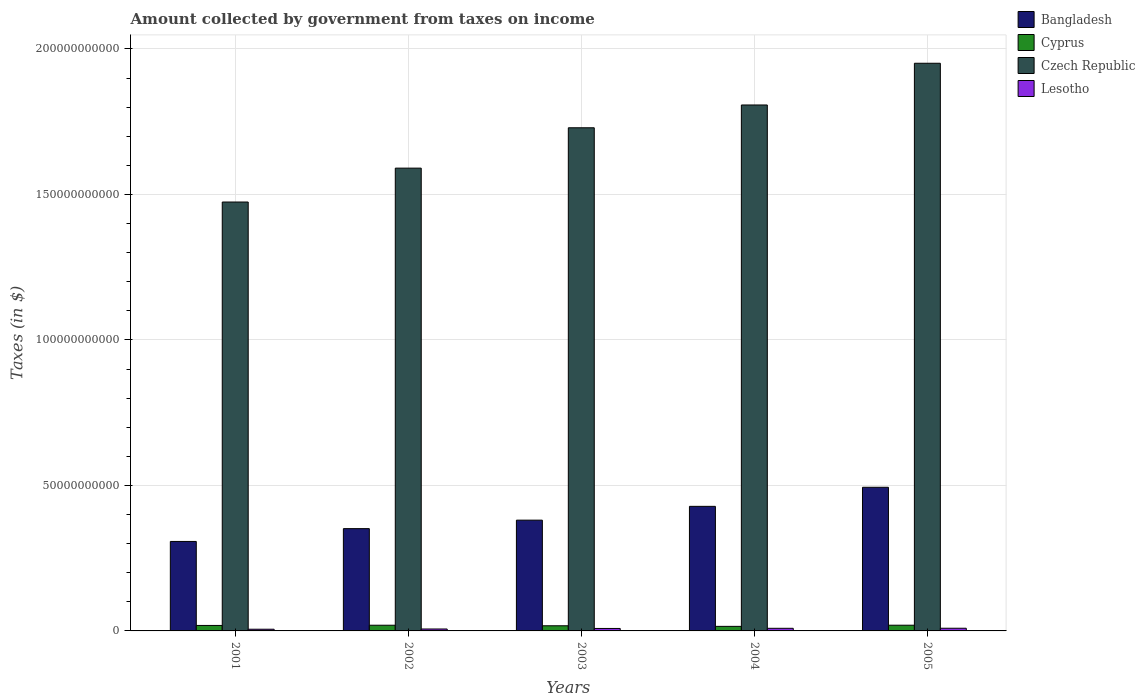How many groups of bars are there?
Provide a succinct answer. 5. In how many cases, is the number of bars for a given year not equal to the number of legend labels?
Provide a succinct answer. 0. What is the amount collected by government from taxes on income in Lesotho in 2005?
Ensure brevity in your answer.  9.20e+08. Across all years, what is the maximum amount collected by government from taxes on income in Bangladesh?
Offer a terse response. 4.94e+1. Across all years, what is the minimum amount collected by government from taxes on income in Czech Republic?
Your answer should be compact. 1.47e+11. In which year was the amount collected by government from taxes on income in Cyprus maximum?
Your answer should be very brief. 2005. In which year was the amount collected by government from taxes on income in Bangladesh minimum?
Make the answer very short. 2001. What is the total amount collected by government from taxes on income in Lesotho in the graph?
Offer a very short reply. 3.90e+09. What is the difference between the amount collected by government from taxes on income in Bangladesh in 2002 and that in 2005?
Make the answer very short. -1.42e+1. What is the difference between the amount collected by government from taxes on income in Czech Republic in 2001 and the amount collected by government from taxes on income in Lesotho in 2002?
Offer a terse response. 1.47e+11. What is the average amount collected by government from taxes on income in Cyprus per year?
Make the answer very short. 1.83e+09. In the year 2003, what is the difference between the amount collected by government from taxes on income in Cyprus and amount collected by government from taxes on income in Bangladesh?
Your answer should be compact. -3.63e+1. What is the ratio of the amount collected by government from taxes on income in Bangladesh in 2001 to that in 2003?
Ensure brevity in your answer.  0.81. What is the difference between the highest and the second highest amount collected by government from taxes on income in Bangladesh?
Offer a very short reply. 6.56e+09. What is the difference between the highest and the lowest amount collected by government from taxes on income in Lesotho?
Make the answer very short. 3.40e+08. Is the sum of the amount collected by government from taxes on income in Cyprus in 2001 and 2005 greater than the maximum amount collected by government from taxes on income in Czech Republic across all years?
Offer a very short reply. No. What does the 2nd bar from the left in 2004 represents?
Keep it short and to the point. Cyprus. What does the 3rd bar from the right in 2003 represents?
Ensure brevity in your answer.  Cyprus. Is it the case that in every year, the sum of the amount collected by government from taxes on income in Cyprus and amount collected by government from taxes on income in Czech Republic is greater than the amount collected by government from taxes on income in Bangladesh?
Make the answer very short. Yes. How many bars are there?
Give a very brief answer. 20. Are all the bars in the graph horizontal?
Ensure brevity in your answer.  No. Does the graph contain any zero values?
Offer a terse response. No. Does the graph contain grids?
Keep it short and to the point. Yes. Where does the legend appear in the graph?
Ensure brevity in your answer.  Top right. How many legend labels are there?
Your answer should be compact. 4. How are the legend labels stacked?
Make the answer very short. Vertical. What is the title of the graph?
Ensure brevity in your answer.  Amount collected by government from taxes on income. What is the label or title of the X-axis?
Provide a succinct answer. Years. What is the label or title of the Y-axis?
Keep it short and to the point. Taxes (in $). What is the Taxes (in $) of Bangladesh in 2001?
Offer a very short reply. 3.07e+1. What is the Taxes (in $) in Cyprus in 2001?
Ensure brevity in your answer.  1.88e+09. What is the Taxes (in $) in Czech Republic in 2001?
Give a very brief answer. 1.47e+11. What is the Taxes (in $) in Lesotho in 2001?
Your response must be concise. 5.80e+08. What is the Taxes (in $) of Bangladesh in 2002?
Your response must be concise. 3.52e+1. What is the Taxes (in $) of Cyprus in 2002?
Keep it short and to the point. 1.96e+09. What is the Taxes (in $) of Czech Republic in 2002?
Your response must be concise. 1.59e+11. What is the Taxes (in $) of Lesotho in 2002?
Your answer should be compact. 6.63e+08. What is the Taxes (in $) in Bangladesh in 2003?
Offer a terse response. 3.81e+1. What is the Taxes (in $) of Cyprus in 2003?
Keep it short and to the point. 1.77e+09. What is the Taxes (in $) in Czech Republic in 2003?
Your answer should be compact. 1.73e+11. What is the Taxes (in $) of Lesotho in 2003?
Ensure brevity in your answer.  8.44e+08. What is the Taxes (in $) in Bangladesh in 2004?
Provide a succinct answer. 4.28e+1. What is the Taxes (in $) of Cyprus in 2004?
Provide a short and direct response. 1.56e+09. What is the Taxes (in $) of Czech Republic in 2004?
Your response must be concise. 1.81e+11. What is the Taxes (in $) in Lesotho in 2004?
Make the answer very short. 8.97e+08. What is the Taxes (in $) of Bangladesh in 2005?
Provide a short and direct response. 4.94e+1. What is the Taxes (in $) of Cyprus in 2005?
Offer a terse response. 1.96e+09. What is the Taxes (in $) of Czech Republic in 2005?
Your answer should be very brief. 1.95e+11. What is the Taxes (in $) of Lesotho in 2005?
Provide a succinct answer. 9.20e+08. Across all years, what is the maximum Taxes (in $) in Bangladesh?
Make the answer very short. 4.94e+1. Across all years, what is the maximum Taxes (in $) in Cyprus?
Your answer should be compact. 1.96e+09. Across all years, what is the maximum Taxes (in $) of Czech Republic?
Offer a very short reply. 1.95e+11. Across all years, what is the maximum Taxes (in $) in Lesotho?
Make the answer very short. 9.20e+08. Across all years, what is the minimum Taxes (in $) in Bangladesh?
Ensure brevity in your answer.  3.07e+1. Across all years, what is the minimum Taxes (in $) of Cyprus?
Give a very brief answer. 1.56e+09. Across all years, what is the minimum Taxes (in $) in Czech Republic?
Your response must be concise. 1.47e+11. Across all years, what is the minimum Taxes (in $) of Lesotho?
Offer a terse response. 5.80e+08. What is the total Taxes (in $) in Bangladesh in the graph?
Provide a short and direct response. 1.96e+11. What is the total Taxes (in $) of Cyprus in the graph?
Keep it short and to the point. 9.13e+09. What is the total Taxes (in $) of Czech Republic in the graph?
Your response must be concise. 8.55e+11. What is the total Taxes (in $) of Lesotho in the graph?
Provide a succinct answer. 3.90e+09. What is the difference between the Taxes (in $) in Bangladesh in 2001 and that in 2002?
Your answer should be compact. -4.40e+09. What is the difference between the Taxes (in $) of Cyprus in 2001 and that in 2002?
Make the answer very short. -7.14e+07. What is the difference between the Taxes (in $) of Czech Republic in 2001 and that in 2002?
Offer a very short reply. -1.16e+1. What is the difference between the Taxes (in $) in Lesotho in 2001 and that in 2002?
Your answer should be very brief. -8.36e+07. What is the difference between the Taxes (in $) of Bangladesh in 2001 and that in 2003?
Ensure brevity in your answer.  -7.31e+09. What is the difference between the Taxes (in $) of Cyprus in 2001 and that in 2003?
Provide a succinct answer. 1.18e+08. What is the difference between the Taxes (in $) in Czech Republic in 2001 and that in 2003?
Offer a terse response. -2.55e+1. What is the difference between the Taxes (in $) in Lesotho in 2001 and that in 2003?
Offer a terse response. -2.65e+08. What is the difference between the Taxes (in $) of Bangladesh in 2001 and that in 2004?
Keep it short and to the point. -1.21e+1. What is the difference between the Taxes (in $) of Cyprus in 2001 and that in 2004?
Make the answer very short. 3.21e+08. What is the difference between the Taxes (in $) of Czech Republic in 2001 and that in 2004?
Your answer should be compact. -3.33e+1. What is the difference between the Taxes (in $) in Lesotho in 2001 and that in 2004?
Provide a succinct answer. -3.17e+08. What is the difference between the Taxes (in $) of Bangladesh in 2001 and that in 2005?
Provide a succinct answer. -1.86e+1. What is the difference between the Taxes (in $) of Cyprus in 2001 and that in 2005?
Provide a short and direct response. -7.60e+07. What is the difference between the Taxes (in $) in Czech Republic in 2001 and that in 2005?
Offer a very short reply. -4.77e+1. What is the difference between the Taxes (in $) of Lesotho in 2001 and that in 2005?
Your response must be concise. -3.40e+08. What is the difference between the Taxes (in $) of Bangladesh in 2002 and that in 2003?
Keep it short and to the point. -2.91e+09. What is the difference between the Taxes (in $) in Cyprus in 2002 and that in 2003?
Provide a succinct answer. 1.89e+08. What is the difference between the Taxes (in $) in Czech Republic in 2002 and that in 2003?
Provide a short and direct response. -1.39e+1. What is the difference between the Taxes (in $) of Lesotho in 2002 and that in 2003?
Your answer should be very brief. -1.81e+08. What is the difference between the Taxes (in $) of Bangladesh in 2002 and that in 2004?
Your answer should be compact. -7.66e+09. What is the difference between the Taxes (in $) of Cyprus in 2002 and that in 2004?
Offer a very short reply. 3.92e+08. What is the difference between the Taxes (in $) of Czech Republic in 2002 and that in 2004?
Give a very brief answer. -2.17e+1. What is the difference between the Taxes (in $) in Lesotho in 2002 and that in 2004?
Your answer should be compact. -2.34e+08. What is the difference between the Taxes (in $) of Bangladesh in 2002 and that in 2005?
Ensure brevity in your answer.  -1.42e+1. What is the difference between the Taxes (in $) in Cyprus in 2002 and that in 2005?
Provide a succinct answer. -4.61e+06. What is the difference between the Taxes (in $) in Czech Republic in 2002 and that in 2005?
Your answer should be compact. -3.60e+1. What is the difference between the Taxes (in $) in Lesotho in 2002 and that in 2005?
Ensure brevity in your answer.  -2.57e+08. What is the difference between the Taxes (in $) in Bangladesh in 2003 and that in 2004?
Give a very brief answer. -4.74e+09. What is the difference between the Taxes (in $) in Cyprus in 2003 and that in 2004?
Offer a very short reply. 2.03e+08. What is the difference between the Taxes (in $) in Czech Republic in 2003 and that in 2004?
Offer a terse response. -7.83e+09. What is the difference between the Taxes (in $) of Lesotho in 2003 and that in 2004?
Ensure brevity in your answer.  -5.27e+07. What is the difference between the Taxes (in $) of Bangladesh in 2003 and that in 2005?
Offer a terse response. -1.13e+1. What is the difference between the Taxes (in $) of Cyprus in 2003 and that in 2005?
Make the answer very short. -1.94e+08. What is the difference between the Taxes (in $) in Czech Republic in 2003 and that in 2005?
Ensure brevity in your answer.  -2.22e+1. What is the difference between the Taxes (in $) in Lesotho in 2003 and that in 2005?
Provide a succinct answer. -7.57e+07. What is the difference between the Taxes (in $) in Bangladesh in 2004 and that in 2005?
Ensure brevity in your answer.  -6.56e+09. What is the difference between the Taxes (in $) in Cyprus in 2004 and that in 2005?
Give a very brief answer. -3.97e+08. What is the difference between the Taxes (in $) of Czech Republic in 2004 and that in 2005?
Your answer should be very brief. -1.43e+1. What is the difference between the Taxes (in $) of Lesotho in 2004 and that in 2005?
Your answer should be very brief. -2.30e+07. What is the difference between the Taxes (in $) in Bangladesh in 2001 and the Taxes (in $) in Cyprus in 2002?
Your response must be concise. 2.88e+1. What is the difference between the Taxes (in $) in Bangladesh in 2001 and the Taxes (in $) in Czech Republic in 2002?
Make the answer very short. -1.28e+11. What is the difference between the Taxes (in $) in Bangladesh in 2001 and the Taxes (in $) in Lesotho in 2002?
Provide a succinct answer. 3.01e+1. What is the difference between the Taxes (in $) of Cyprus in 2001 and the Taxes (in $) of Czech Republic in 2002?
Offer a terse response. -1.57e+11. What is the difference between the Taxes (in $) in Cyprus in 2001 and the Taxes (in $) in Lesotho in 2002?
Provide a succinct answer. 1.22e+09. What is the difference between the Taxes (in $) in Czech Republic in 2001 and the Taxes (in $) in Lesotho in 2002?
Make the answer very short. 1.47e+11. What is the difference between the Taxes (in $) in Bangladesh in 2001 and the Taxes (in $) in Cyprus in 2003?
Your response must be concise. 2.90e+1. What is the difference between the Taxes (in $) in Bangladesh in 2001 and the Taxes (in $) in Czech Republic in 2003?
Ensure brevity in your answer.  -1.42e+11. What is the difference between the Taxes (in $) of Bangladesh in 2001 and the Taxes (in $) of Lesotho in 2003?
Provide a succinct answer. 2.99e+1. What is the difference between the Taxes (in $) of Cyprus in 2001 and the Taxes (in $) of Czech Republic in 2003?
Give a very brief answer. -1.71e+11. What is the difference between the Taxes (in $) of Cyprus in 2001 and the Taxes (in $) of Lesotho in 2003?
Provide a short and direct response. 1.04e+09. What is the difference between the Taxes (in $) of Czech Republic in 2001 and the Taxes (in $) of Lesotho in 2003?
Give a very brief answer. 1.47e+11. What is the difference between the Taxes (in $) in Bangladesh in 2001 and the Taxes (in $) in Cyprus in 2004?
Provide a short and direct response. 2.92e+1. What is the difference between the Taxes (in $) of Bangladesh in 2001 and the Taxes (in $) of Czech Republic in 2004?
Give a very brief answer. -1.50e+11. What is the difference between the Taxes (in $) of Bangladesh in 2001 and the Taxes (in $) of Lesotho in 2004?
Provide a succinct answer. 2.99e+1. What is the difference between the Taxes (in $) of Cyprus in 2001 and the Taxes (in $) of Czech Republic in 2004?
Give a very brief answer. -1.79e+11. What is the difference between the Taxes (in $) of Cyprus in 2001 and the Taxes (in $) of Lesotho in 2004?
Ensure brevity in your answer.  9.87e+08. What is the difference between the Taxes (in $) in Czech Republic in 2001 and the Taxes (in $) in Lesotho in 2004?
Ensure brevity in your answer.  1.46e+11. What is the difference between the Taxes (in $) of Bangladesh in 2001 and the Taxes (in $) of Cyprus in 2005?
Offer a terse response. 2.88e+1. What is the difference between the Taxes (in $) in Bangladesh in 2001 and the Taxes (in $) in Czech Republic in 2005?
Provide a short and direct response. -1.64e+11. What is the difference between the Taxes (in $) in Bangladesh in 2001 and the Taxes (in $) in Lesotho in 2005?
Your answer should be very brief. 2.98e+1. What is the difference between the Taxes (in $) of Cyprus in 2001 and the Taxes (in $) of Czech Republic in 2005?
Ensure brevity in your answer.  -1.93e+11. What is the difference between the Taxes (in $) of Cyprus in 2001 and the Taxes (in $) of Lesotho in 2005?
Ensure brevity in your answer.  9.64e+08. What is the difference between the Taxes (in $) of Czech Republic in 2001 and the Taxes (in $) of Lesotho in 2005?
Provide a short and direct response. 1.46e+11. What is the difference between the Taxes (in $) in Bangladesh in 2002 and the Taxes (in $) in Cyprus in 2003?
Ensure brevity in your answer.  3.34e+1. What is the difference between the Taxes (in $) of Bangladesh in 2002 and the Taxes (in $) of Czech Republic in 2003?
Provide a short and direct response. -1.38e+11. What is the difference between the Taxes (in $) of Bangladesh in 2002 and the Taxes (in $) of Lesotho in 2003?
Give a very brief answer. 3.43e+1. What is the difference between the Taxes (in $) of Cyprus in 2002 and the Taxes (in $) of Czech Republic in 2003?
Ensure brevity in your answer.  -1.71e+11. What is the difference between the Taxes (in $) of Cyprus in 2002 and the Taxes (in $) of Lesotho in 2003?
Offer a terse response. 1.11e+09. What is the difference between the Taxes (in $) of Czech Republic in 2002 and the Taxes (in $) of Lesotho in 2003?
Make the answer very short. 1.58e+11. What is the difference between the Taxes (in $) of Bangladesh in 2002 and the Taxes (in $) of Cyprus in 2004?
Ensure brevity in your answer.  3.36e+1. What is the difference between the Taxes (in $) of Bangladesh in 2002 and the Taxes (in $) of Czech Republic in 2004?
Your response must be concise. -1.46e+11. What is the difference between the Taxes (in $) in Bangladesh in 2002 and the Taxes (in $) in Lesotho in 2004?
Give a very brief answer. 3.43e+1. What is the difference between the Taxes (in $) of Cyprus in 2002 and the Taxes (in $) of Czech Republic in 2004?
Offer a terse response. -1.79e+11. What is the difference between the Taxes (in $) of Cyprus in 2002 and the Taxes (in $) of Lesotho in 2004?
Give a very brief answer. 1.06e+09. What is the difference between the Taxes (in $) of Czech Republic in 2002 and the Taxes (in $) of Lesotho in 2004?
Provide a succinct answer. 1.58e+11. What is the difference between the Taxes (in $) in Bangladesh in 2002 and the Taxes (in $) in Cyprus in 2005?
Your answer should be very brief. 3.32e+1. What is the difference between the Taxes (in $) in Bangladesh in 2002 and the Taxes (in $) in Czech Republic in 2005?
Provide a short and direct response. -1.60e+11. What is the difference between the Taxes (in $) in Bangladesh in 2002 and the Taxes (in $) in Lesotho in 2005?
Your answer should be very brief. 3.42e+1. What is the difference between the Taxes (in $) of Cyprus in 2002 and the Taxes (in $) of Czech Republic in 2005?
Provide a short and direct response. -1.93e+11. What is the difference between the Taxes (in $) of Cyprus in 2002 and the Taxes (in $) of Lesotho in 2005?
Keep it short and to the point. 1.04e+09. What is the difference between the Taxes (in $) in Czech Republic in 2002 and the Taxes (in $) in Lesotho in 2005?
Give a very brief answer. 1.58e+11. What is the difference between the Taxes (in $) of Bangladesh in 2003 and the Taxes (in $) of Cyprus in 2004?
Offer a very short reply. 3.65e+1. What is the difference between the Taxes (in $) of Bangladesh in 2003 and the Taxes (in $) of Czech Republic in 2004?
Give a very brief answer. -1.43e+11. What is the difference between the Taxes (in $) in Bangladesh in 2003 and the Taxes (in $) in Lesotho in 2004?
Ensure brevity in your answer.  3.72e+1. What is the difference between the Taxes (in $) of Cyprus in 2003 and the Taxes (in $) of Czech Republic in 2004?
Offer a terse response. -1.79e+11. What is the difference between the Taxes (in $) of Cyprus in 2003 and the Taxes (in $) of Lesotho in 2004?
Provide a short and direct response. 8.69e+08. What is the difference between the Taxes (in $) in Czech Republic in 2003 and the Taxes (in $) in Lesotho in 2004?
Ensure brevity in your answer.  1.72e+11. What is the difference between the Taxes (in $) of Bangladesh in 2003 and the Taxes (in $) of Cyprus in 2005?
Provide a short and direct response. 3.61e+1. What is the difference between the Taxes (in $) in Bangladesh in 2003 and the Taxes (in $) in Czech Republic in 2005?
Provide a succinct answer. -1.57e+11. What is the difference between the Taxes (in $) in Bangladesh in 2003 and the Taxes (in $) in Lesotho in 2005?
Give a very brief answer. 3.71e+1. What is the difference between the Taxes (in $) in Cyprus in 2003 and the Taxes (in $) in Czech Republic in 2005?
Keep it short and to the point. -1.93e+11. What is the difference between the Taxes (in $) in Cyprus in 2003 and the Taxes (in $) in Lesotho in 2005?
Keep it short and to the point. 8.46e+08. What is the difference between the Taxes (in $) in Czech Republic in 2003 and the Taxes (in $) in Lesotho in 2005?
Offer a terse response. 1.72e+11. What is the difference between the Taxes (in $) in Bangladesh in 2004 and the Taxes (in $) in Cyprus in 2005?
Keep it short and to the point. 4.08e+1. What is the difference between the Taxes (in $) in Bangladesh in 2004 and the Taxes (in $) in Czech Republic in 2005?
Ensure brevity in your answer.  -1.52e+11. What is the difference between the Taxes (in $) in Bangladesh in 2004 and the Taxes (in $) in Lesotho in 2005?
Ensure brevity in your answer.  4.19e+1. What is the difference between the Taxes (in $) of Cyprus in 2004 and the Taxes (in $) of Czech Republic in 2005?
Provide a succinct answer. -1.94e+11. What is the difference between the Taxes (in $) of Cyprus in 2004 and the Taxes (in $) of Lesotho in 2005?
Keep it short and to the point. 6.43e+08. What is the difference between the Taxes (in $) of Czech Republic in 2004 and the Taxes (in $) of Lesotho in 2005?
Provide a short and direct response. 1.80e+11. What is the average Taxes (in $) of Bangladesh per year?
Offer a very short reply. 3.92e+1. What is the average Taxes (in $) in Cyprus per year?
Ensure brevity in your answer.  1.83e+09. What is the average Taxes (in $) of Czech Republic per year?
Your answer should be compact. 1.71e+11. What is the average Taxes (in $) of Lesotho per year?
Your answer should be very brief. 7.81e+08. In the year 2001, what is the difference between the Taxes (in $) of Bangladesh and Taxes (in $) of Cyprus?
Offer a terse response. 2.89e+1. In the year 2001, what is the difference between the Taxes (in $) of Bangladesh and Taxes (in $) of Czech Republic?
Provide a short and direct response. -1.17e+11. In the year 2001, what is the difference between the Taxes (in $) in Bangladesh and Taxes (in $) in Lesotho?
Your answer should be compact. 3.02e+1. In the year 2001, what is the difference between the Taxes (in $) of Cyprus and Taxes (in $) of Czech Republic?
Provide a short and direct response. -1.46e+11. In the year 2001, what is the difference between the Taxes (in $) of Cyprus and Taxes (in $) of Lesotho?
Your answer should be very brief. 1.30e+09. In the year 2001, what is the difference between the Taxes (in $) in Czech Republic and Taxes (in $) in Lesotho?
Your answer should be very brief. 1.47e+11. In the year 2002, what is the difference between the Taxes (in $) in Bangladesh and Taxes (in $) in Cyprus?
Make the answer very short. 3.32e+1. In the year 2002, what is the difference between the Taxes (in $) of Bangladesh and Taxes (in $) of Czech Republic?
Ensure brevity in your answer.  -1.24e+11. In the year 2002, what is the difference between the Taxes (in $) in Bangladesh and Taxes (in $) in Lesotho?
Offer a terse response. 3.45e+1. In the year 2002, what is the difference between the Taxes (in $) of Cyprus and Taxes (in $) of Czech Republic?
Offer a very short reply. -1.57e+11. In the year 2002, what is the difference between the Taxes (in $) in Cyprus and Taxes (in $) in Lesotho?
Ensure brevity in your answer.  1.29e+09. In the year 2002, what is the difference between the Taxes (in $) in Czech Republic and Taxes (in $) in Lesotho?
Offer a very short reply. 1.58e+11. In the year 2003, what is the difference between the Taxes (in $) in Bangladesh and Taxes (in $) in Cyprus?
Ensure brevity in your answer.  3.63e+1. In the year 2003, what is the difference between the Taxes (in $) in Bangladesh and Taxes (in $) in Czech Republic?
Provide a short and direct response. -1.35e+11. In the year 2003, what is the difference between the Taxes (in $) in Bangladesh and Taxes (in $) in Lesotho?
Your answer should be compact. 3.72e+1. In the year 2003, what is the difference between the Taxes (in $) of Cyprus and Taxes (in $) of Czech Republic?
Provide a succinct answer. -1.71e+11. In the year 2003, what is the difference between the Taxes (in $) in Cyprus and Taxes (in $) in Lesotho?
Keep it short and to the point. 9.22e+08. In the year 2003, what is the difference between the Taxes (in $) of Czech Republic and Taxes (in $) of Lesotho?
Make the answer very short. 1.72e+11. In the year 2004, what is the difference between the Taxes (in $) in Bangladesh and Taxes (in $) in Cyprus?
Your answer should be very brief. 4.12e+1. In the year 2004, what is the difference between the Taxes (in $) in Bangladesh and Taxes (in $) in Czech Republic?
Your response must be concise. -1.38e+11. In the year 2004, what is the difference between the Taxes (in $) of Bangladesh and Taxes (in $) of Lesotho?
Offer a terse response. 4.19e+1. In the year 2004, what is the difference between the Taxes (in $) of Cyprus and Taxes (in $) of Czech Republic?
Make the answer very short. -1.79e+11. In the year 2004, what is the difference between the Taxes (in $) in Cyprus and Taxes (in $) in Lesotho?
Your answer should be compact. 6.66e+08. In the year 2004, what is the difference between the Taxes (in $) in Czech Republic and Taxes (in $) in Lesotho?
Keep it short and to the point. 1.80e+11. In the year 2005, what is the difference between the Taxes (in $) in Bangladesh and Taxes (in $) in Cyprus?
Your answer should be very brief. 4.74e+1. In the year 2005, what is the difference between the Taxes (in $) in Bangladesh and Taxes (in $) in Czech Republic?
Your answer should be compact. -1.46e+11. In the year 2005, what is the difference between the Taxes (in $) in Bangladesh and Taxes (in $) in Lesotho?
Ensure brevity in your answer.  4.84e+1. In the year 2005, what is the difference between the Taxes (in $) in Cyprus and Taxes (in $) in Czech Republic?
Provide a succinct answer. -1.93e+11. In the year 2005, what is the difference between the Taxes (in $) of Cyprus and Taxes (in $) of Lesotho?
Provide a short and direct response. 1.04e+09. In the year 2005, what is the difference between the Taxes (in $) of Czech Republic and Taxes (in $) of Lesotho?
Offer a very short reply. 1.94e+11. What is the ratio of the Taxes (in $) of Bangladesh in 2001 to that in 2002?
Keep it short and to the point. 0.87. What is the ratio of the Taxes (in $) of Cyprus in 2001 to that in 2002?
Give a very brief answer. 0.96. What is the ratio of the Taxes (in $) of Czech Republic in 2001 to that in 2002?
Ensure brevity in your answer.  0.93. What is the ratio of the Taxes (in $) in Lesotho in 2001 to that in 2002?
Offer a terse response. 0.87. What is the ratio of the Taxes (in $) of Bangladesh in 2001 to that in 2003?
Keep it short and to the point. 0.81. What is the ratio of the Taxes (in $) in Cyprus in 2001 to that in 2003?
Provide a short and direct response. 1.07. What is the ratio of the Taxes (in $) in Czech Republic in 2001 to that in 2003?
Give a very brief answer. 0.85. What is the ratio of the Taxes (in $) of Lesotho in 2001 to that in 2003?
Give a very brief answer. 0.69. What is the ratio of the Taxes (in $) in Bangladesh in 2001 to that in 2004?
Your answer should be very brief. 0.72. What is the ratio of the Taxes (in $) of Cyprus in 2001 to that in 2004?
Ensure brevity in your answer.  1.21. What is the ratio of the Taxes (in $) of Czech Republic in 2001 to that in 2004?
Provide a short and direct response. 0.82. What is the ratio of the Taxes (in $) in Lesotho in 2001 to that in 2004?
Offer a very short reply. 0.65. What is the ratio of the Taxes (in $) in Bangladesh in 2001 to that in 2005?
Offer a very short reply. 0.62. What is the ratio of the Taxes (in $) of Cyprus in 2001 to that in 2005?
Provide a succinct answer. 0.96. What is the ratio of the Taxes (in $) in Czech Republic in 2001 to that in 2005?
Make the answer very short. 0.76. What is the ratio of the Taxes (in $) in Lesotho in 2001 to that in 2005?
Offer a very short reply. 0.63. What is the ratio of the Taxes (in $) of Bangladesh in 2002 to that in 2003?
Your answer should be compact. 0.92. What is the ratio of the Taxes (in $) in Cyprus in 2002 to that in 2003?
Offer a very short reply. 1.11. What is the ratio of the Taxes (in $) of Czech Republic in 2002 to that in 2003?
Your answer should be compact. 0.92. What is the ratio of the Taxes (in $) in Lesotho in 2002 to that in 2003?
Provide a succinct answer. 0.79. What is the ratio of the Taxes (in $) of Bangladesh in 2002 to that in 2004?
Offer a terse response. 0.82. What is the ratio of the Taxes (in $) in Cyprus in 2002 to that in 2004?
Keep it short and to the point. 1.25. What is the ratio of the Taxes (in $) in Czech Republic in 2002 to that in 2004?
Ensure brevity in your answer.  0.88. What is the ratio of the Taxes (in $) in Lesotho in 2002 to that in 2004?
Give a very brief answer. 0.74. What is the ratio of the Taxes (in $) in Bangladesh in 2002 to that in 2005?
Your answer should be compact. 0.71. What is the ratio of the Taxes (in $) in Czech Republic in 2002 to that in 2005?
Ensure brevity in your answer.  0.82. What is the ratio of the Taxes (in $) in Lesotho in 2002 to that in 2005?
Keep it short and to the point. 0.72. What is the ratio of the Taxes (in $) of Bangladesh in 2003 to that in 2004?
Keep it short and to the point. 0.89. What is the ratio of the Taxes (in $) of Cyprus in 2003 to that in 2004?
Offer a very short reply. 1.13. What is the ratio of the Taxes (in $) of Czech Republic in 2003 to that in 2004?
Offer a very short reply. 0.96. What is the ratio of the Taxes (in $) in Lesotho in 2003 to that in 2004?
Provide a short and direct response. 0.94. What is the ratio of the Taxes (in $) in Bangladesh in 2003 to that in 2005?
Your response must be concise. 0.77. What is the ratio of the Taxes (in $) in Cyprus in 2003 to that in 2005?
Offer a very short reply. 0.9. What is the ratio of the Taxes (in $) of Czech Republic in 2003 to that in 2005?
Offer a very short reply. 0.89. What is the ratio of the Taxes (in $) of Lesotho in 2003 to that in 2005?
Your answer should be compact. 0.92. What is the ratio of the Taxes (in $) of Bangladesh in 2004 to that in 2005?
Your response must be concise. 0.87. What is the ratio of the Taxes (in $) in Cyprus in 2004 to that in 2005?
Ensure brevity in your answer.  0.8. What is the ratio of the Taxes (in $) in Czech Republic in 2004 to that in 2005?
Ensure brevity in your answer.  0.93. What is the difference between the highest and the second highest Taxes (in $) of Bangladesh?
Keep it short and to the point. 6.56e+09. What is the difference between the highest and the second highest Taxes (in $) in Cyprus?
Provide a short and direct response. 4.61e+06. What is the difference between the highest and the second highest Taxes (in $) in Czech Republic?
Provide a short and direct response. 1.43e+1. What is the difference between the highest and the second highest Taxes (in $) of Lesotho?
Offer a very short reply. 2.30e+07. What is the difference between the highest and the lowest Taxes (in $) of Bangladesh?
Provide a short and direct response. 1.86e+1. What is the difference between the highest and the lowest Taxes (in $) in Cyprus?
Provide a short and direct response. 3.97e+08. What is the difference between the highest and the lowest Taxes (in $) of Czech Republic?
Give a very brief answer. 4.77e+1. What is the difference between the highest and the lowest Taxes (in $) in Lesotho?
Ensure brevity in your answer.  3.40e+08. 